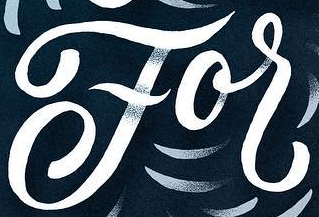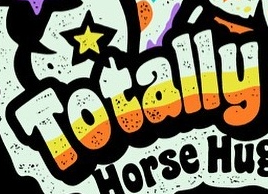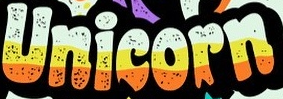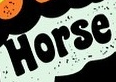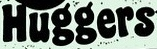Transcribe the words shown in these images in order, separated by a semicolon. For; Totally; Unicorn; Horse; Huggers 